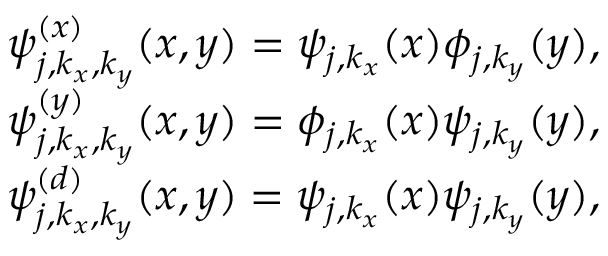Convert formula to latex. <formula><loc_0><loc_0><loc_500><loc_500>\begin{array} { r } { \psi _ { j , k _ { x } , k _ { y } } ^ { ( x ) } ( x , y ) = \psi _ { j , k _ { x } } ( x ) \phi _ { j , k _ { y } } ( y ) , } \\ { \psi _ { j , k _ { x } , k _ { y } } ^ { ( y ) } ( x , y ) = \phi _ { j , k _ { x } } ( x ) \psi _ { j , k _ { y } } ( y ) , } \\ { \psi _ { j , k _ { x } , k _ { y } } ^ { ( d ) } ( x , y ) = \psi _ { j , k _ { x } } ( x ) \psi _ { j , k _ { y } } ( y ) , } \end{array}</formula> 